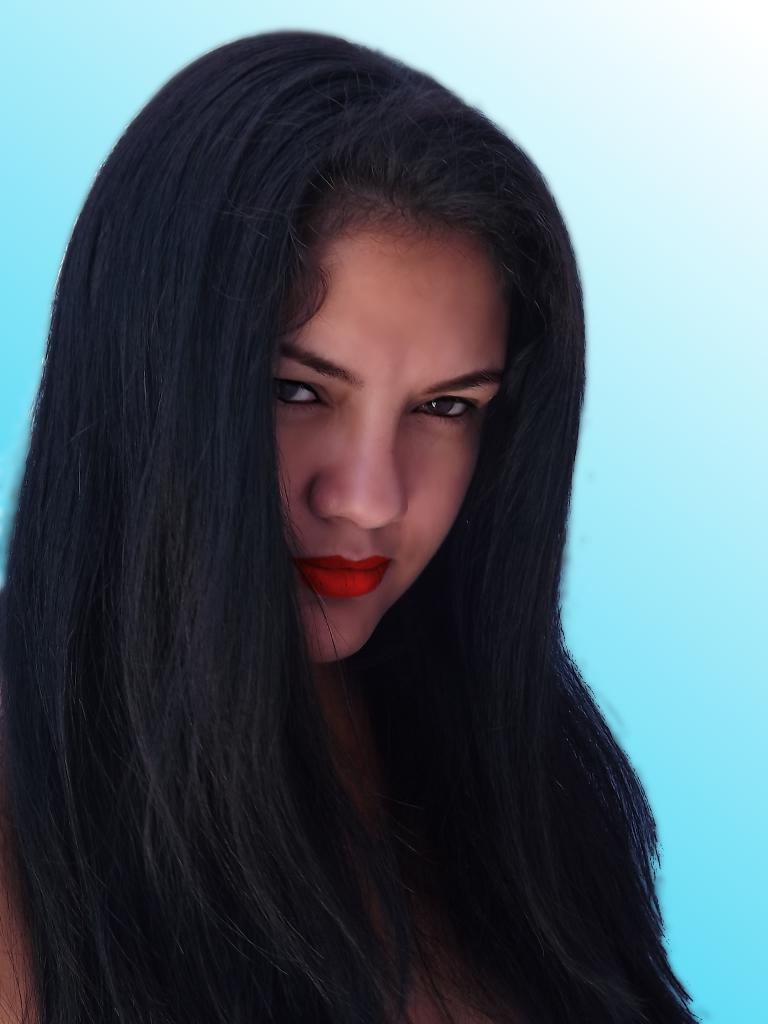Who is the main subject in the image? There is a lady in the center of the image. What can be seen in the background of the image? There is a wall in the background of the image. How many men are resting in the image? There are no men present in the image, and no one is resting. 